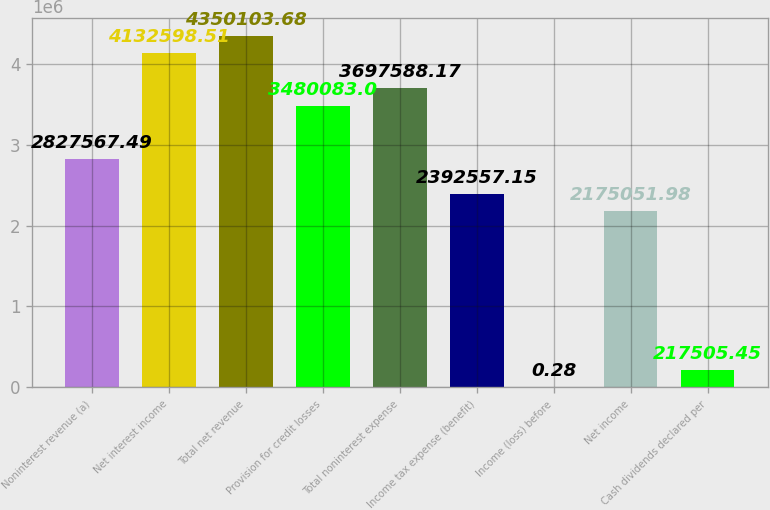Convert chart. <chart><loc_0><loc_0><loc_500><loc_500><bar_chart><fcel>Noninterest revenue (a)<fcel>Net interest income<fcel>Total net revenue<fcel>Provision for credit losses<fcel>Total noninterest expense<fcel>Income tax expense (benefit)<fcel>Income (loss) before<fcel>Net income<fcel>Cash dividends declared per<nl><fcel>2.82757e+06<fcel>4.1326e+06<fcel>4.3501e+06<fcel>3.48008e+06<fcel>3.69759e+06<fcel>2.39256e+06<fcel>0.28<fcel>2.17505e+06<fcel>217505<nl></chart> 